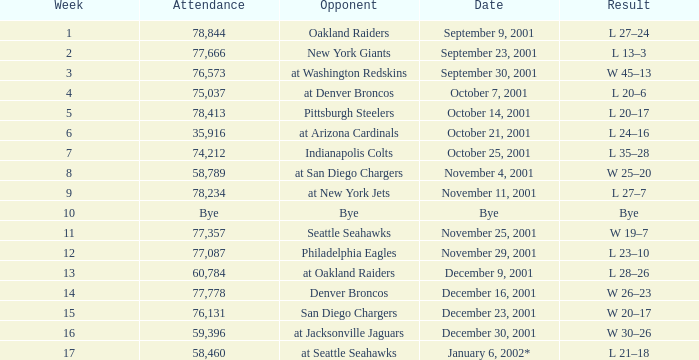How many attended the game on December 16, 2001? 77778.0. Could you parse the entire table? {'header': ['Week', 'Attendance', 'Opponent', 'Date', 'Result'], 'rows': [['1', '78,844', 'Oakland Raiders', 'September 9, 2001', 'L 27–24'], ['2', '77,666', 'New York Giants', 'September 23, 2001', 'L 13–3'], ['3', '76,573', 'at Washington Redskins', 'September 30, 2001', 'W 45–13'], ['4', '75,037', 'at Denver Broncos', 'October 7, 2001', 'L 20–6'], ['5', '78,413', 'Pittsburgh Steelers', 'October 14, 2001', 'L 20–17'], ['6', '35,916', 'at Arizona Cardinals', 'October 21, 2001', 'L 24–16'], ['7', '74,212', 'Indianapolis Colts', 'October 25, 2001', 'L 35–28'], ['8', '58,789', 'at San Diego Chargers', 'November 4, 2001', 'W 25–20'], ['9', '78,234', 'at New York Jets', 'November 11, 2001', 'L 27–7'], ['10', 'Bye', 'Bye', 'Bye', 'Bye'], ['11', '77,357', 'Seattle Seahawks', 'November 25, 2001', 'W 19–7'], ['12', '77,087', 'Philadelphia Eagles', 'November 29, 2001', 'L 23–10'], ['13', '60,784', 'at Oakland Raiders', 'December 9, 2001', 'L 28–26'], ['14', '77,778', 'Denver Broncos', 'December 16, 2001', 'W 26–23'], ['15', '76,131', 'San Diego Chargers', 'December 23, 2001', 'W 20–17'], ['16', '59,396', 'at Jacksonville Jaguars', 'December 30, 2001', 'W 30–26'], ['17', '58,460', 'at Seattle Seahawks', 'January 6, 2002*', 'L 21–18']]} 